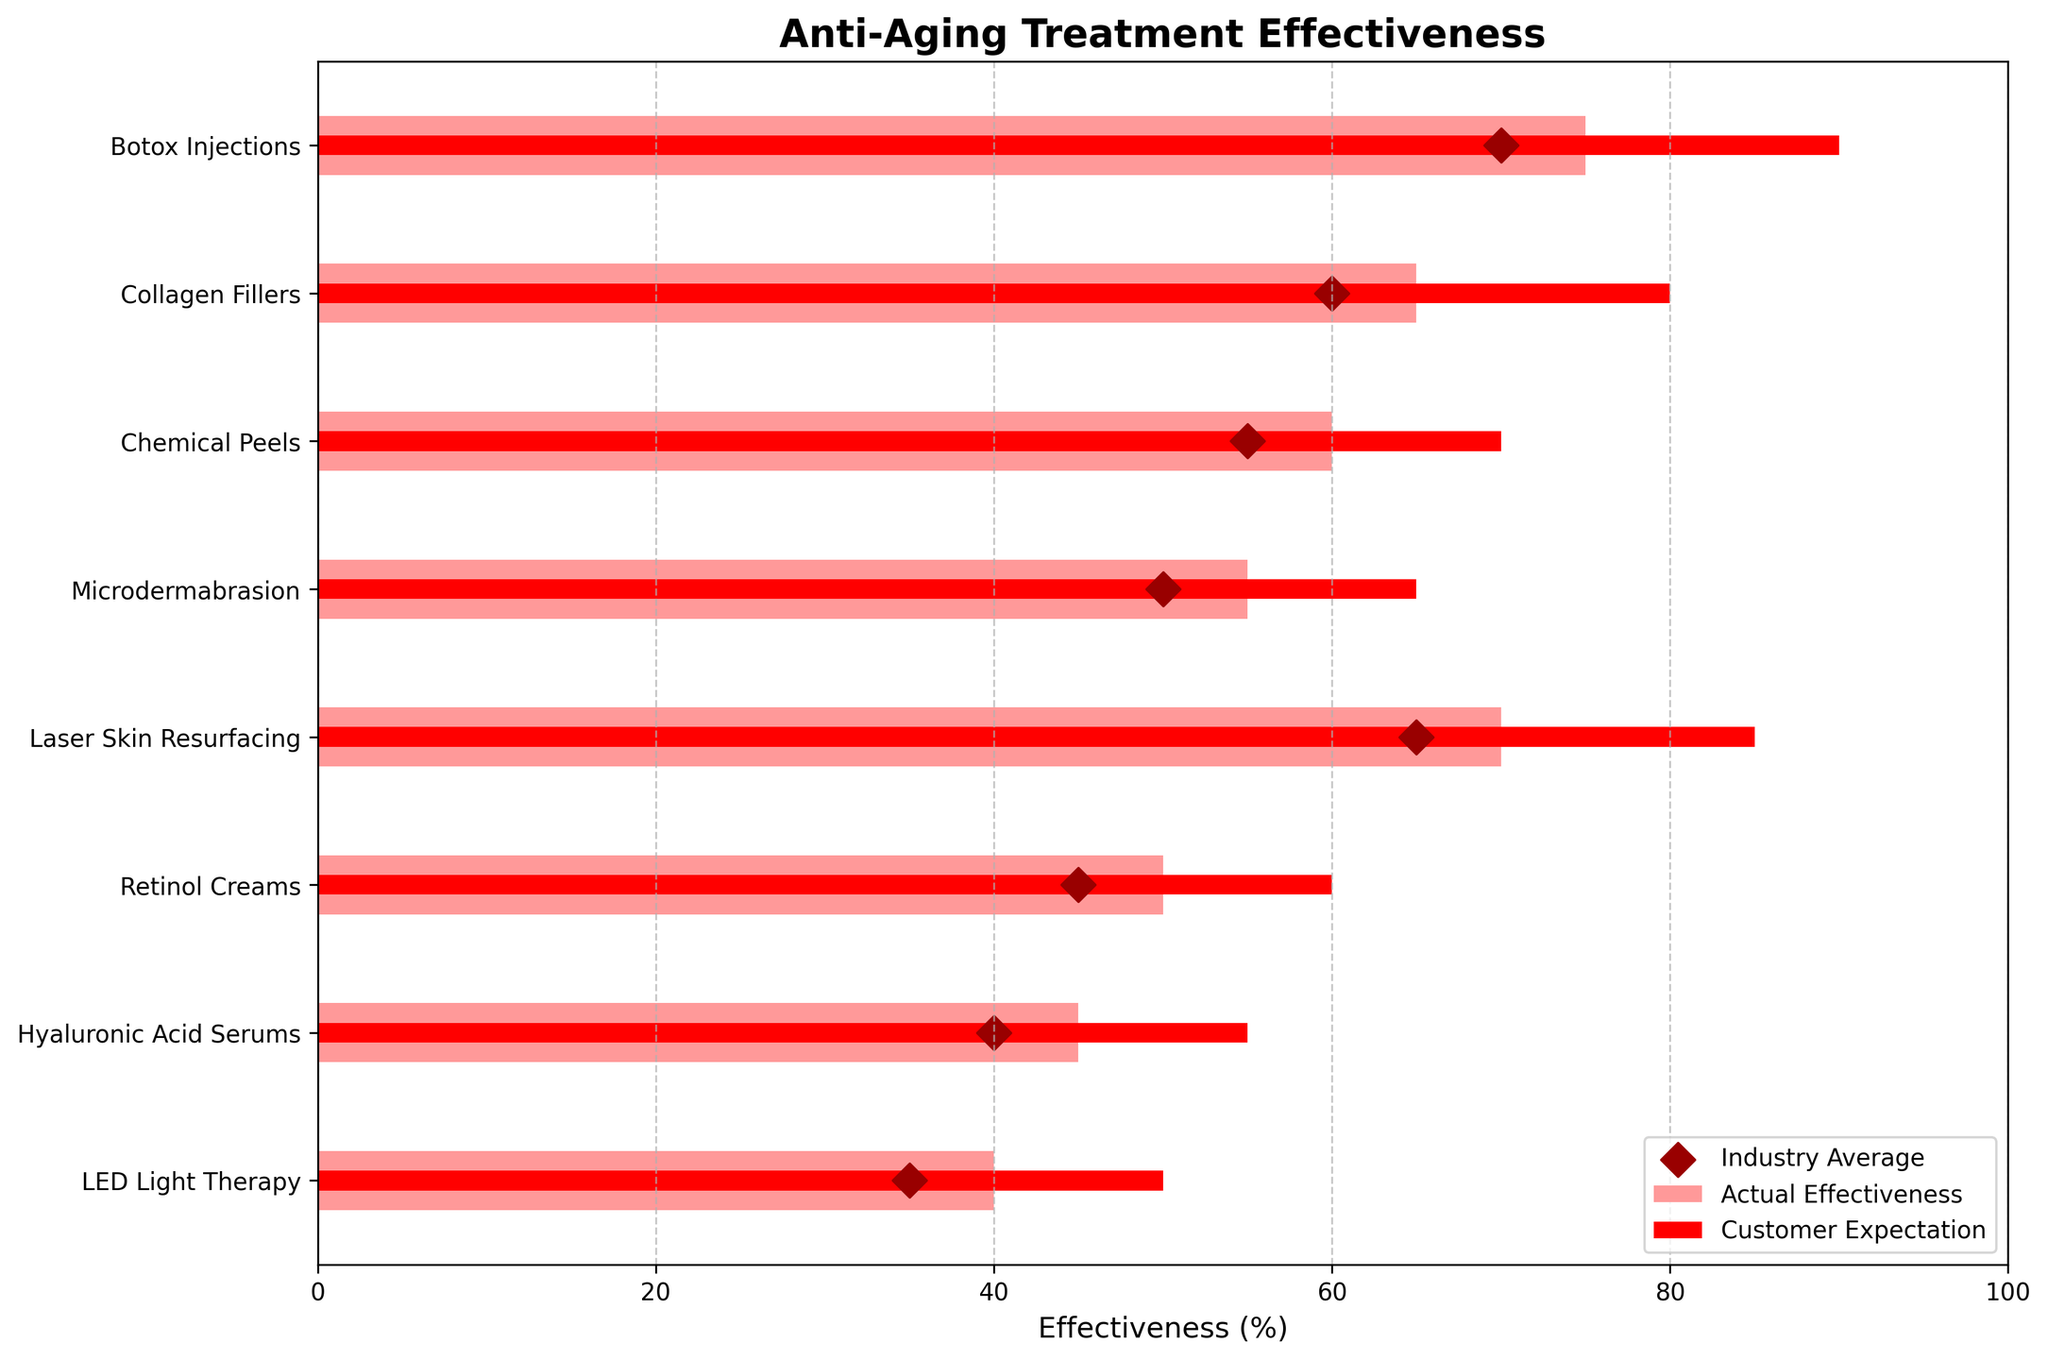What is the title of the chart? The title is text displayed at the top of the chart. The chart's title is "Anti-Aging Treatment Effectiveness".
Answer: Anti-Aging Treatment Effectiveness Which treatment has the highest actual effectiveness? By looking at the lengths of the pink bars, the longest bar represents the treatment with the highest actual effectiveness. "Botox Injections" has the highest actual effectiveness at 75%.
Answer: Botox Injections What's the difference between actual effectiveness and customer expectations for Botox Injections? For Botox Injections, the actual effectiveness is 75% and customer expectations are 90%. The difference is calculated as 90% - 75% = 15%.
Answer: 15% Which treatment's actual effectiveness is closest to the industry average? We compare the lengths of the pink bars with the positions of the dark red diamond markers. For "Botox Injections", "Collagen Fillers", and "Laser Skin Resurfacing", the actual effectiveness is very close to the industry average. Specifically measured, "Botox Injections" and "Laser Skin Resurfacing" have actual effectiveness closest to their industry average.
Answer: Botox Injections and Laser Skin Resurfacing Which treatment has the smallest gap between customer expectations and actual effectiveness? By comparing the red bars (customer expectations) and pink bars (actual effectiveness), the smallest gap is seen in "Retinol Creams", where the expectation is 60% and actual effectiveness is 50%, making the gap 10%.
Answer: Retinol Creams How does the actual effectiveness of Retinol Creams compare against the industry average? The actual effectiveness of Retinol Creams is 50%, and the industry average is 45%. Thus, Retinol Creams perform 5% better than the industry average.
Answer: 5% better Which treatments have actual effectiveness lower than customer expectations? All treatments listed have actual effectiveness bars shorter than their customer expectation bars. To be specific: Botox Injections, Collagen Fillers, Chemical Peels, Microdermabrasion, Laser Skin Resurfacing, Retinol Creams, Hyaluronic Acid Serums, LED Light Therapy.
Answer: All treatments How much more effective is Botox Injections compared to Hyaluronic Acid Serums? The actual effectiveness of Botox Injections is 75% and for Hyaluronic Acid Serums, it is 45%. The difference is calculated as 75% - 45% = 30%.
Answer: 30% Which two treatments have customer expectations exceeding 80%? By looking at the red bars (customer expectations), "Botox Injections" and "Laser Skin Resurfacing" have expectations of 90% and 85% respectively.
Answer: Botox Injections and Laser Skin Resurfacing 